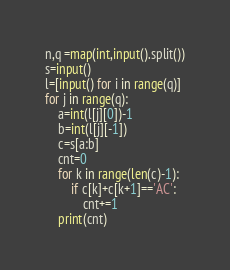<code> <loc_0><loc_0><loc_500><loc_500><_Python_>n,q =map(int,input().split())
s=input()
l=[input() for i in range(q)]
for j in range(q):
    a=int(l[j][0])-1
    b=int(l[j][-1])
    c=s[a:b]
    cnt=0
    for k in range(len(c)-1):
        if c[k]+c[k+1]=='AC':
            cnt+=1
    print(cnt)</code> 